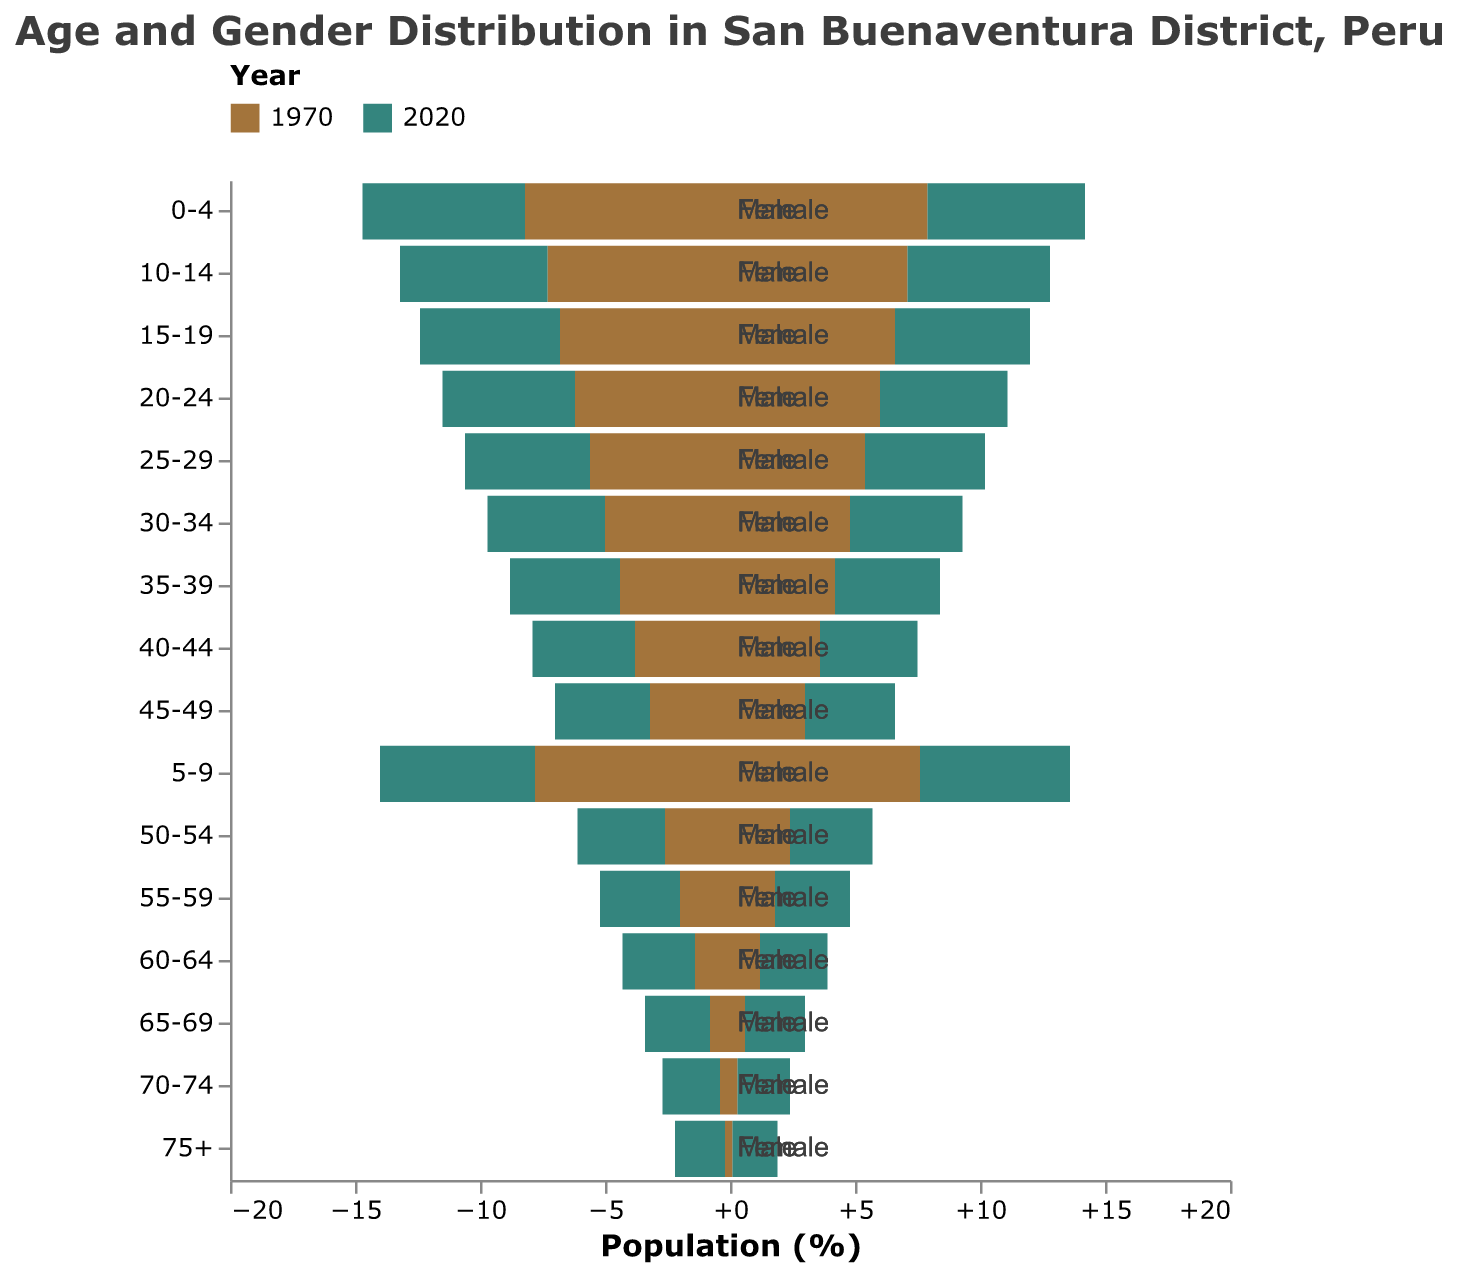What are the colors representing the years 1970 and 2020 in the figure? The colors for years 1970 and 2020 are shown in the legend at the top of the figure. 1970 is represented by a brownish color, and 2020 is represented by a dark green color.
Answer: Brown for 1970, Green for 2020 What age group has the highest percentage of males in 1970? Looking at the left side of the pyramid which represents males in 1970, the 0-4 age group has the highest percentage, indicated by the longest bar.
Answer: 0-4 age group How has the percentage of females aged 70-74 changed from 1970 to 2020? By comparing the length of the bars for females aged 70-74 in 1970 and 2020, it can be seen that the bar for 2020 is longer, indicating an increase in the percentage.
Answer: Increased Which gender saw a more significant percentage increase in the 55-59 age group from 1970 to 2020? By comparing the bar lengths for both males and females in the 55-59 age group between 1970 and 2020, it is observed that both genders have increased significantly but males increased from 2.0% to 3.2% and females from 1.8% to 3.0%. The percentage increase for males is greater.
Answer: Males In 2020, what is the percentage difference between males and females in the 20-24 age group? The 2020 data shows that males in the 20-24 age group are 5.3% and females are 5.1%. The difference is found by subtracting the female percentage from the male percentage, \(5.3 - 5.1 = 0.2\).
Answer: 0.2% Which gender had the smallest percentage of the population in the 65-69 age group in 1970? By examining the bars corresponding to the 65-69 age group in 1970 for both males and females, the female bar is shorter with 0.6% compared to 0.8% for males.
Answer: Females How does the percentage of the population aged 0-4 change from 1970 to 2020 for both genders? For males, the percentage decreases from 8.2% to 6.5%. For females, it decreases from 7.9% to 6.3%.
Answer: Decreased for both genders Which age group in 2020 shows the highest percentage for females? By looking at the heights of the bars correspond to females in 2020, the 0-4 age group has the longest bar, indicating the highest percentage.
Answer: 0-4 age group What is the total percentage of the population aged 45-49 in 2020 for both genders combined? Adding the percentages for males (3.8%) and females (3.6%) in the 45-49 age group in 2020 gives \(3.8 + 3.6 = 7.4\).
Answer: 7.4% In which age group is the gender distribution most balanced in 2020? The bars representing males and females for the 35-39 age group in 2020 are of equal length at 4.4% for both genders, showing the most balanced distribution.
Answer: 35-39 age group 